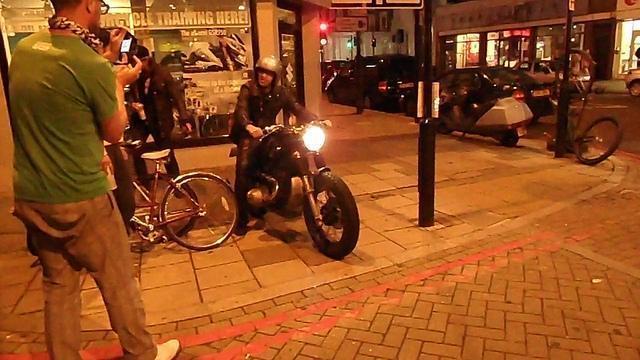How many lights are on the front of the motorcycle?
Give a very brief answer. 1. How many cars can be seen?
Give a very brief answer. 2. How many people are there?
Give a very brief answer. 4. How many bicycles are in the picture?
Give a very brief answer. 2. How many motorcycles can you see?
Give a very brief answer. 2. 